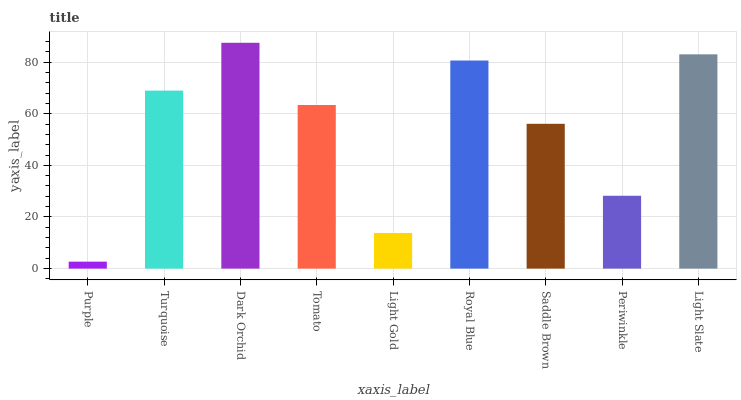Is Purple the minimum?
Answer yes or no. Yes. Is Dark Orchid the maximum?
Answer yes or no. Yes. Is Turquoise the minimum?
Answer yes or no. No. Is Turquoise the maximum?
Answer yes or no. No. Is Turquoise greater than Purple?
Answer yes or no. Yes. Is Purple less than Turquoise?
Answer yes or no. Yes. Is Purple greater than Turquoise?
Answer yes or no. No. Is Turquoise less than Purple?
Answer yes or no. No. Is Tomato the high median?
Answer yes or no. Yes. Is Tomato the low median?
Answer yes or no. Yes. Is Purple the high median?
Answer yes or no. No. Is Royal Blue the low median?
Answer yes or no. No. 